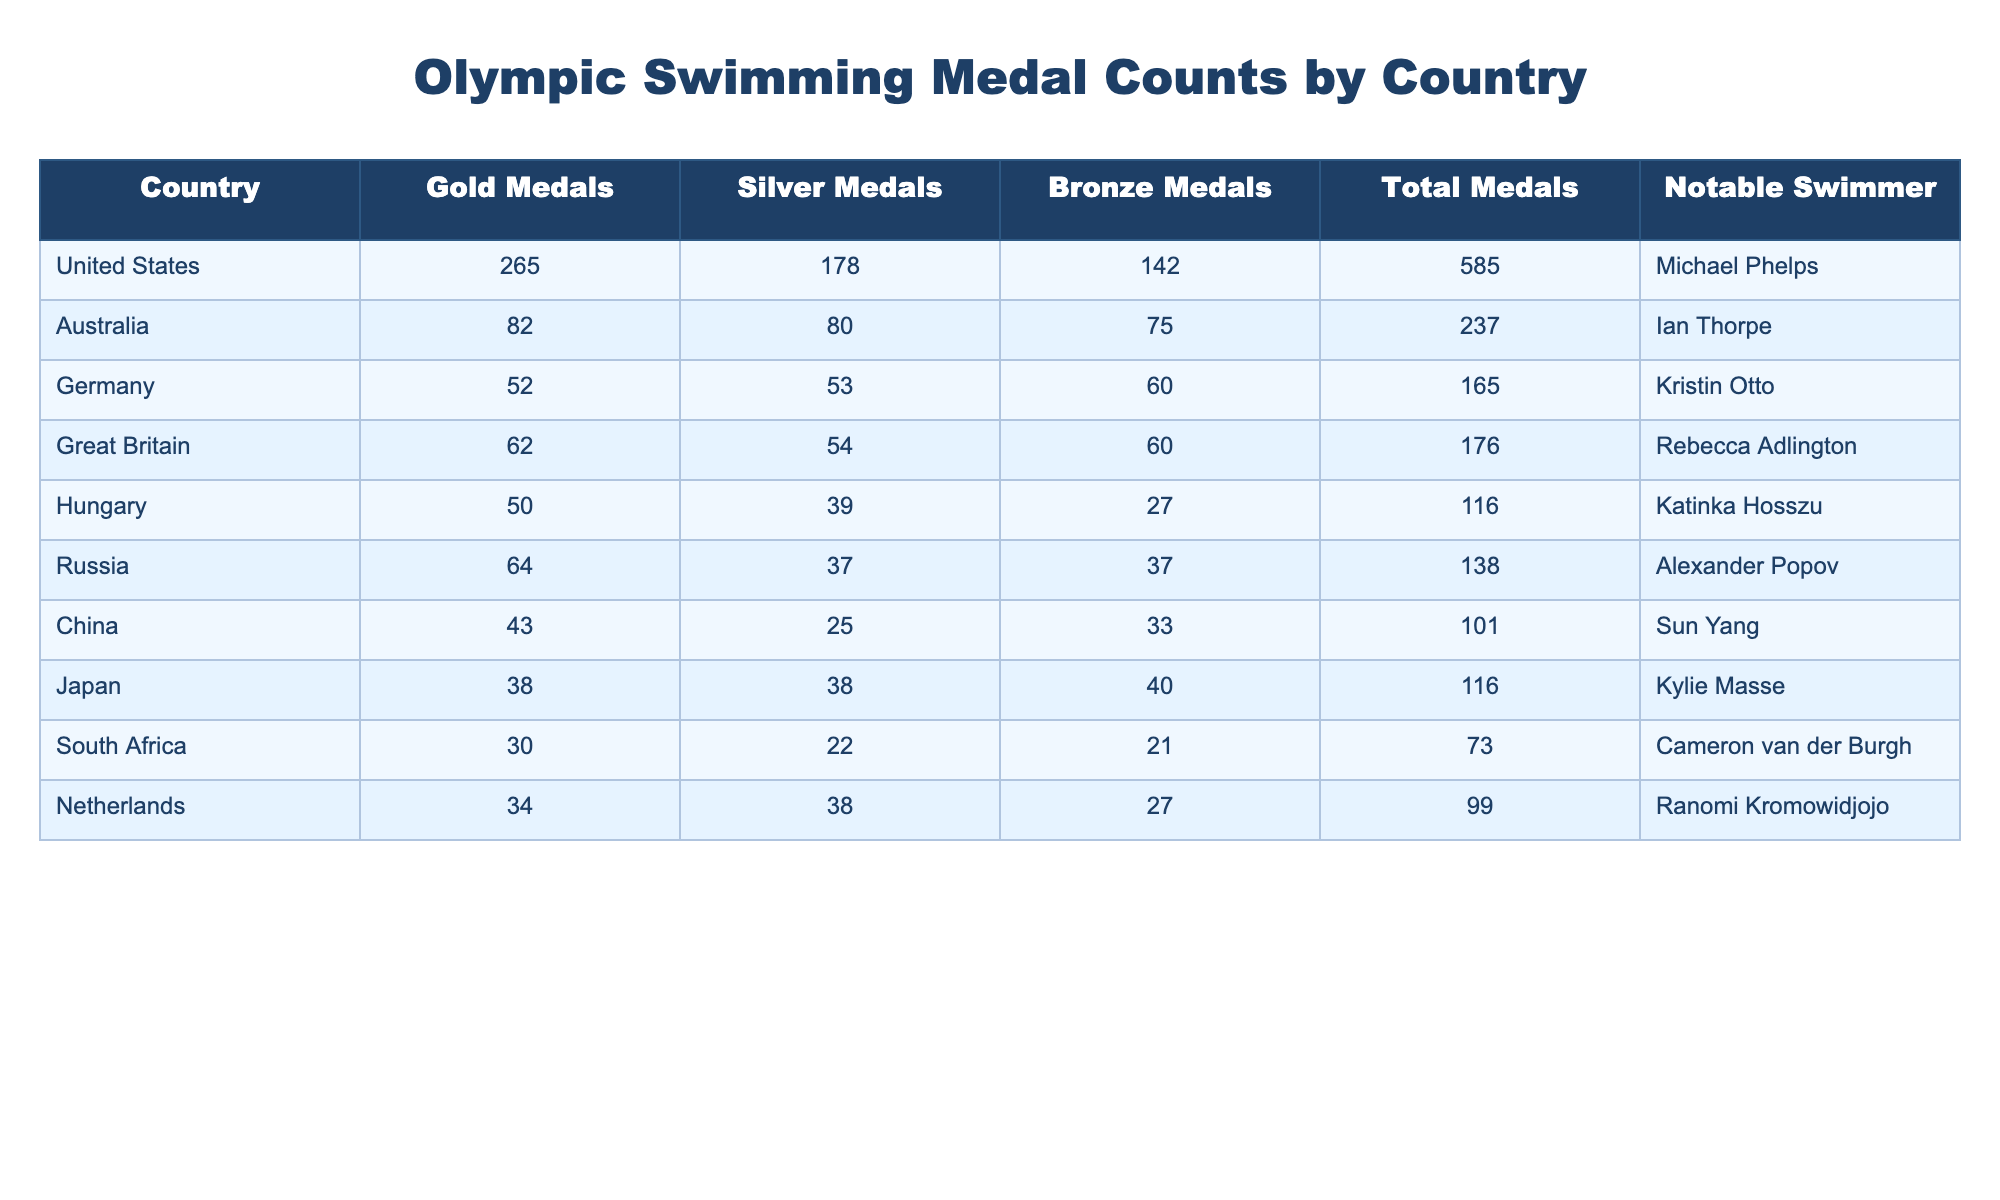What country has the highest number of gold medals? The United States has the highest number of gold medals listed in the table, with a total of 265.
Answer: United States Which country has won the lowest total number of medals? South Africa has the lowest total number of medals in the table, with a total of 73.
Answer: South Africa How many silver medals did Germany win? The number of silver medals won by Germany is 53, which is directly viewed in the respective column for Germany.
Answer: 53 What is the total number of medals earned by Australia and Great Britain combined? To find the total for both countries, we add Australia's total of 237 and Great Britain's total of 176. The calculation is 237 + 176 = 413.
Answer: 413 Which country has more bronze medals, Japan or Hungary? Japan has 40 bronze medals, and Hungary has 27, so Japan has more bronze medals.
Answer: Yes, Japan has more bronze medals Did China win more gold medals than Russia? China has a total of 43 gold medals, while Russia has 64 gold medals. Thus, China did not win more.
Answer: No What is the difference in total medals between the United States and Germany? The United States has 585 total medals, and Germany has 165. The difference is calculated as 585 - 165 = 420.
Answer: 420 Which notable swimmer corresponds to the highest medal count country? The United States corresponds to the highest medal count country, with Michael Phelps noted as the swimmer.
Answer: Michael Phelps If we consider only gold medals, which country has the second highest count? Australia has the second highest gold medal count with 82, following the United States with 265.
Answer: Australia 